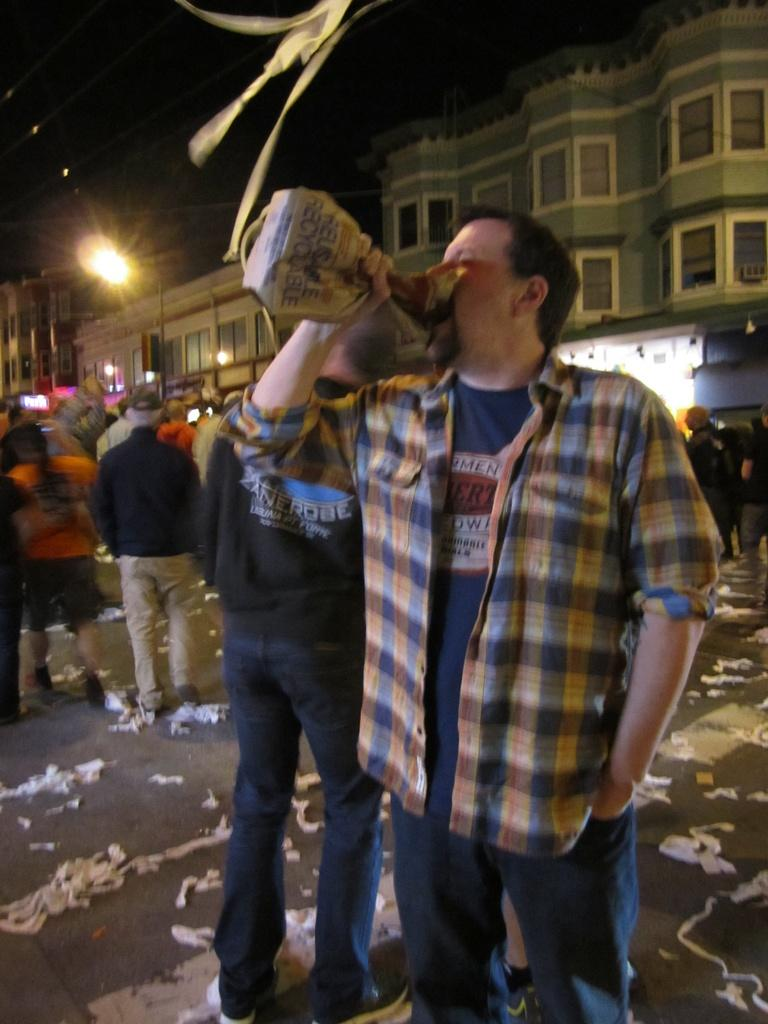What is the person holding in the image? The person is holding an object in the image. Can you describe the group of people in the image? There is a group of people standing in the image. What type of structures can be seen in the background of the image? There are buildings visible in the image. What is visible in the sky in the image? The sky is visible in the image. What type of spark can be seen coming from the treatment in the image? There is no treatment or spark present in the image. 